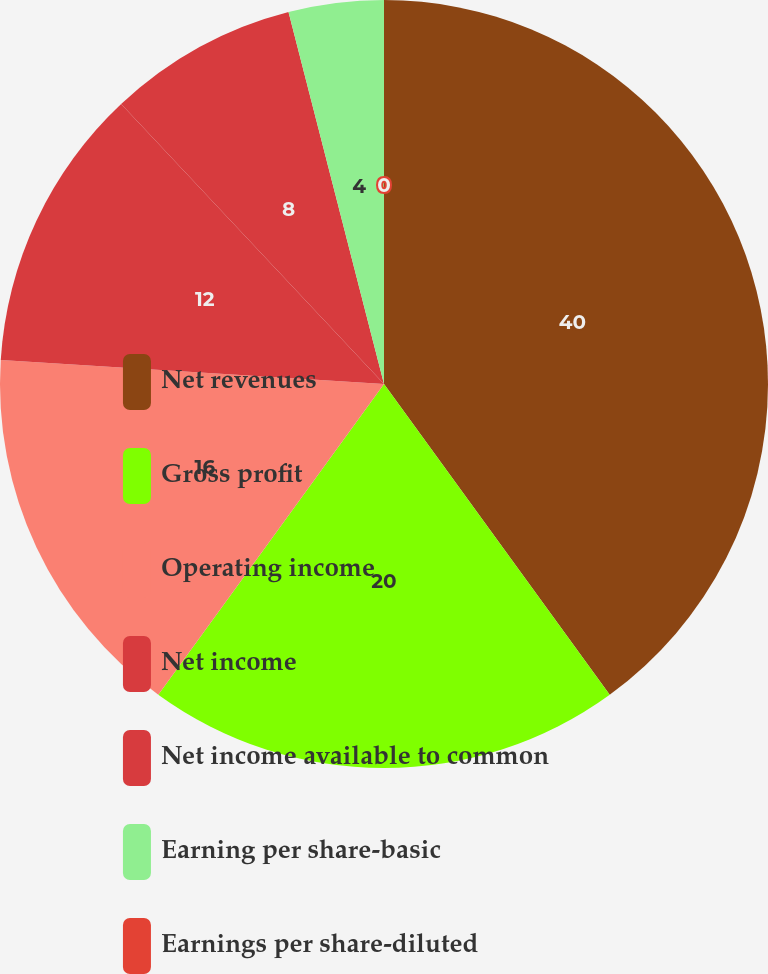Convert chart to OTSL. <chart><loc_0><loc_0><loc_500><loc_500><pie_chart><fcel>Net revenues<fcel>Gross profit<fcel>Operating income<fcel>Net income<fcel>Net income available to common<fcel>Earning per share-basic<fcel>Earnings per share-diluted<nl><fcel>40.0%<fcel>20.0%<fcel>16.0%<fcel>12.0%<fcel>8.0%<fcel>4.0%<fcel>0.0%<nl></chart> 